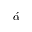Convert formula to latex. <formula><loc_0><loc_0><loc_500><loc_500>\acute { \alpha }</formula> 